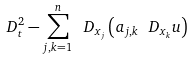Convert formula to latex. <formula><loc_0><loc_0><loc_500><loc_500>\ D _ { t } ^ { 2 } - \sum _ { j , k = 1 } ^ { n } \ D _ { x _ { j } } \left ( a _ { j , k } \ D _ { x _ { k } } u \right )</formula> 